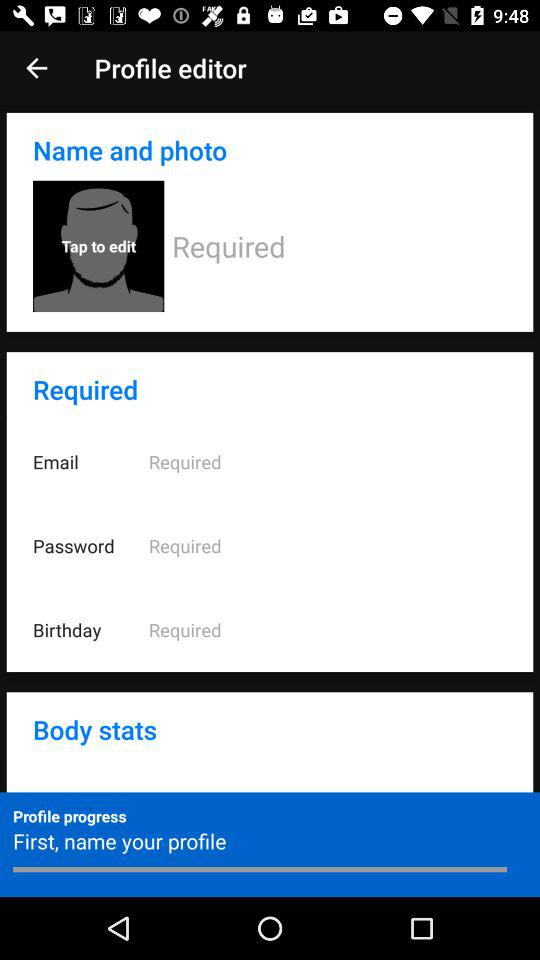What is the significance of the progress bar at the bottom of the profile editor? The progress bar indicates how complete your profile is. It prompts you to start by naming your profile, suggesting this is one of the first steps in filling out your profile information. How does completing my profile benefit me? A completed profile can enhance your experience on the platform by enabling personalized services, improving social connectivity, and ensuring proper account security and recovery options. 